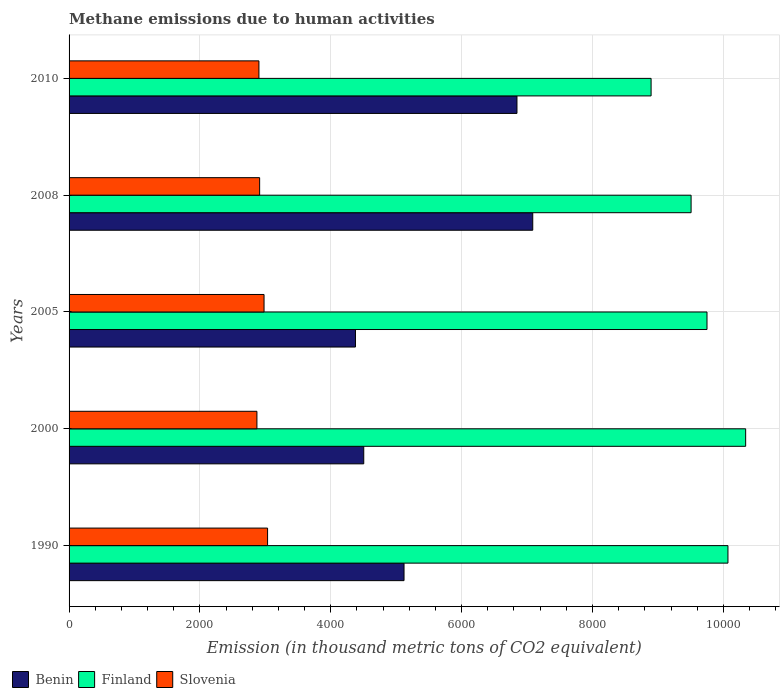How many different coloured bars are there?
Your answer should be compact. 3. How many bars are there on the 3rd tick from the bottom?
Ensure brevity in your answer.  3. What is the label of the 1st group of bars from the top?
Give a very brief answer. 2010. What is the amount of methane emitted in Benin in 2000?
Your answer should be compact. 4503.8. Across all years, what is the maximum amount of methane emitted in Finland?
Ensure brevity in your answer.  1.03e+04. Across all years, what is the minimum amount of methane emitted in Finland?
Provide a succinct answer. 8895.5. In which year was the amount of methane emitted in Finland maximum?
Offer a terse response. 2000. What is the total amount of methane emitted in Slovenia in the graph?
Your response must be concise. 1.47e+04. What is the difference between the amount of methane emitted in Benin in 1990 and that in 2010?
Offer a terse response. -1726.1. What is the difference between the amount of methane emitted in Benin in 2005 and the amount of methane emitted in Slovenia in 2000?
Your response must be concise. 1506.2. What is the average amount of methane emitted in Slovenia per year?
Provide a short and direct response. 2939.82. In the year 2010, what is the difference between the amount of methane emitted in Benin and amount of methane emitted in Finland?
Provide a short and direct response. -2049.9. What is the ratio of the amount of methane emitted in Slovenia in 1990 to that in 2005?
Keep it short and to the point. 1.02. Is the difference between the amount of methane emitted in Benin in 2000 and 2008 greater than the difference between the amount of methane emitted in Finland in 2000 and 2008?
Offer a terse response. No. What is the difference between the highest and the second highest amount of methane emitted in Slovenia?
Your answer should be very brief. 54. What is the difference between the highest and the lowest amount of methane emitted in Benin?
Your answer should be very brief. 2709.3. In how many years, is the amount of methane emitted in Finland greater than the average amount of methane emitted in Finland taken over all years?
Provide a short and direct response. 3. What does the 1st bar from the top in 2005 represents?
Provide a succinct answer. Slovenia. What does the 2nd bar from the bottom in 2010 represents?
Ensure brevity in your answer.  Finland. How many bars are there?
Your response must be concise. 15. Are all the bars in the graph horizontal?
Offer a terse response. Yes. How many years are there in the graph?
Offer a very short reply. 5. Does the graph contain any zero values?
Give a very brief answer. No. Where does the legend appear in the graph?
Give a very brief answer. Bottom left. How are the legend labels stacked?
Offer a terse response. Horizontal. What is the title of the graph?
Give a very brief answer. Methane emissions due to human activities. Does "Jamaica" appear as one of the legend labels in the graph?
Offer a terse response. No. What is the label or title of the X-axis?
Offer a very short reply. Emission (in thousand metric tons of CO2 equivalent). What is the Emission (in thousand metric tons of CO2 equivalent) of Benin in 1990?
Provide a short and direct response. 5119.5. What is the Emission (in thousand metric tons of CO2 equivalent) of Finland in 1990?
Offer a terse response. 1.01e+04. What is the Emission (in thousand metric tons of CO2 equivalent) of Slovenia in 1990?
Your answer should be compact. 3033.9. What is the Emission (in thousand metric tons of CO2 equivalent) in Benin in 2000?
Ensure brevity in your answer.  4503.8. What is the Emission (in thousand metric tons of CO2 equivalent) in Finland in 2000?
Give a very brief answer. 1.03e+04. What is the Emission (in thousand metric tons of CO2 equivalent) of Slovenia in 2000?
Ensure brevity in your answer.  2871.1. What is the Emission (in thousand metric tons of CO2 equivalent) in Benin in 2005?
Ensure brevity in your answer.  4377.3. What is the Emission (in thousand metric tons of CO2 equivalent) in Finland in 2005?
Give a very brief answer. 9750. What is the Emission (in thousand metric tons of CO2 equivalent) of Slovenia in 2005?
Offer a very short reply. 2979.9. What is the Emission (in thousand metric tons of CO2 equivalent) in Benin in 2008?
Your answer should be compact. 7086.6. What is the Emission (in thousand metric tons of CO2 equivalent) of Finland in 2008?
Keep it short and to the point. 9506.7. What is the Emission (in thousand metric tons of CO2 equivalent) of Slovenia in 2008?
Give a very brief answer. 2912.5. What is the Emission (in thousand metric tons of CO2 equivalent) of Benin in 2010?
Your answer should be compact. 6845.6. What is the Emission (in thousand metric tons of CO2 equivalent) in Finland in 2010?
Offer a terse response. 8895.5. What is the Emission (in thousand metric tons of CO2 equivalent) of Slovenia in 2010?
Keep it short and to the point. 2901.7. Across all years, what is the maximum Emission (in thousand metric tons of CO2 equivalent) in Benin?
Ensure brevity in your answer.  7086.6. Across all years, what is the maximum Emission (in thousand metric tons of CO2 equivalent) of Finland?
Provide a succinct answer. 1.03e+04. Across all years, what is the maximum Emission (in thousand metric tons of CO2 equivalent) of Slovenia?
Your answer should be compact. 3033.9. Across all years, what is the minimum Emission (in thousand metric tons of CO2 equivalent) in Benin?
Your answer should be very brief. 4377.3. Across all years, what is the minimum Emission (in thousand metric tons of CO2 equivalent) of Finland?
Make the answer very short. 8895.5. Across all years, what is the minimum Emission (in thousand metric tons of CO2 equivalent) of Slovenia?
Your answer should be compact. 2871.1. What is the total Emission (in thousand metric tons of CO2 equivalent) of Benin in the graph?
Your response must be concise. 2.79e+04. What is the total Emission (in thousand metric tons of CO2 equivalent) in Finland in the graph?
Your answer should be very brief. 4.86e+04. What is the total Emission (in thousand metric tons of CO2 equivalent) of Slovenia in the graph?
Provide a succinct answer. 1.47e+04. What is the difference between the Emission (in thousand metric tons of CO2 equivalent) in Benin in 1990 and that in 2000?
Make the answer very short. 615.7. What is the difference between the Emission (in thousand metric tons of CO2 equivalent) of Finland in 1990 and that in 2000?
Provide a short and direct response. -270.6. What is the difference between the Emission (in thousand metric tons of CO2 equivalent) of Slovenia in 1990 and that in 2000?
Your response must be concise. 162.8. What is the difference between the Emission (in thousand metric tons of CO2 equivalent) in Benin in 1990 and that in 2005?
Offer a terse response. 742.2. What is the difference between the Emission (in thousand metric tons of CO2 equivalent) in Finland in 1990 and that in 2005?
Offer a terse response. 320.2. What is the difference between the Emission (in thousand metric tons of CO2 equivalent) in Benin in 1990 and that in 2008?
Your answer should be very brief. -1967.1. What is the difference between the Emission (in thousand metric tons of CO2 equivalent) of Finland in 1990 and that in 2008?
Ensure brevity in your answer.  563.5. What is the difference between the Emission (in thousand metric tons of CO2 equivalent) of Slovenia in 1990 and that in 2008?
Your answer should be compact. 121.4. What is the difference between the Emission (in thousand metric tons of CO2 equivalent) in Benin in 1990 and that in 2010?
Your response must be concise. -1726.1. What is the difference between the Emission (in thousand metric tons of CO2 equivalent) of Finland in 1990 and that in 2010?
Make the answer very short. 1174.7. What is the difference between the Emission (in thousand metric tons of CO2 equivalent) of Slovenia in 1990 and that in 2010?
Ensure brevity in your answer.  132.2. What is the difference between the Emission (in thousand metric tons of CO2 equivalent) in Benin in 2000 and that in 2005?
Make the answer very short. 126.5. What is the difference between the Emission (in thousand metric tons of CO2 equivalent) in Finland in 2000 and that in 2005?
Offer a terse response. 590.8. What is the difference between the Emission (in thousand metric tons of CO2 equivalent) in Slovenia in 2000 and that in 2005?
Offer a very short reply. -108.8. What is the difference between the Emission (in thousand metric tons of CO2 equivalent) of Benin in 2000 and that in 2008?
Offer a terse response. -2582.8. What is the difference between the Emission (in thousand metric tons of CO2 equivalent) in Finland in 2000 and that in 2008?
Your answer should be compact. 834.1. What is the difference between the Emission (in thousand metric tons of CO2 equivalent) in Slovenia in 2000 and that in 2008?
Your response must be concise. -41.4. What is the difference between the Emission (in thousand metric tons of CO2 equivalent) in Benin in 2000 and that in 2010?
Your answer should be very brief. -2341.8. What is the difference between the Emission (in thousand metric tons of CO2 equivalent) in Finland in 2000 and that in 2010?
Give a very brief answer. 1445.3. What is the difference between the Emission (in thousand metric tons of CO2 equivalent) of Slovenia in 2000 and that in 2010?
Give a very brief answer. -30.6. What is the difference between the Emission (in thousand metric tons of CO2 equivalent) in Benin in 2005 and that in 2008?
Provide a succinct answer. -2709.3. What is the difference between the Emission (in thousand metric tons of CO2 equivalent) of Finland in 2005 and that in 2008?
Your response must be concise. 243.3. What is the difference between the Emission (in thousand metric tons of CO2 equivalent) in Slovenia in 2005 and that in 2008?
Provide a succinct answer. 67.4. What is the difference between the Emission (in thousand metric tons of CO2 equivalent) of Benin in 2005 and that in 2010?
Keep it short and to the point. -2468.3. What is the difference between the Emission (in thousand metric tons of CO2 equivalent) in Finland in 2005 and that in 2010?
Offer a terse response. 854.5. What is the difference between the Emission (in thousand metric tons of CO2 equivalent) in Slovenia in 2005 and that in 2010?
Provide a succinct answer. 78.2. What is the difference between the Emission (in thousand metric tons of CO2 equivalent) of Benin in 2008 and that in 2010?
Your response must be concise. 241. What is the difference between the Emission (in thousand metric tons of CO2 equivalent) of Finland in 2008 and that in 2010?
Your answer should be very brief. 611.2. What is the difference between the Emission (in thousand metric tons of CO2 equivalent) in Slovenia in 2008 and that in 2010?
Provide a succinct answer. 10.8. What is the difference between the Emission (in thousand metric tons of CO2 equivalent) in Benin in 1990 and the Emission (in thousand metric tons of CO2 equivalent) in Finland in 2000?
Your response must be concise. -5221.3. What is the difference between the Emission (in thousand metric tons of CO2 equivalent) of Benin in 1990 and the Emission (in thousand metric tons of CO2 equivalent) of Slovenia in 2000?
Your response must be concise. 2248.4. What is the difference between the Emission (in thousand metric tons of CO2 equivalent) in Finland in 1990 and the Emission (in thousand metric tons of CO2 equivalent) in Slovenia in 2000?
Your response must be concise. 7199.1. What is the difference between the Emission (in thousand metric tons of CO2 equivalent) in Benin in 1990 and the Emission (in thousand metric tons of CO2 equivalent) in Finland in 2005?
Provide a short and direct response. -4630.5. What is the difference between the Emission (in thousand metric tons of CO2 equivalent) in Benin in 1990 and the Emission (in thousand metric tons of CO2 equivalent) in Slovenia in 2005?
Provide a short and direct response. 2139.6. What is the difference between the Emission (in thousand metric tons of CO2 equivalent) in Finland in 1990 and the Emission (in thousand metric tons of CO2 equivalent) in Slovenia in 2005?
Keep it short and to the point. 7090.3. What is the difference between the Emission (in thousand metric tons of CO2 equivalent) in Benin in 1990 and the Emission (in thousand metric tons of CO2 equivalent) in Finland in 2008?
Your answer should be compact. -4387.2. What is the difference between the Emission (in thousand metric tons of CO2 equivalent) in Benin in 1990 and the Emission (in thousand metric tons of CO2 equivalent) in Slovenia in 2008?
Ensure brevity in your answer.  2207. What is the difference between the Emission (in thousand metric tons of CO2 equivalent) in Finland in 1990 and the Emission (in thousand metric tons of CO2 equivalent) in Slovenia in 2008?
Keep it short and to the point. 7157.7. What is the difference between the Emission (in thousand metric tons of CO2 equivalent) of Benin in 1990 and the Emission (in thousand metric tons of CO2 equivalent) of Finland in 2010?
Keep it short and to the point. -3776. What is the difference between the Emission (in thousand metric tons of CO2 equivalent) of Benin in 1990 and the Emission (in thousand metric tons of CO2 equivalent) of Slovenia in 2010?
Provide a short and direct response. 2217.8. What is the difference between the Emission (in thousand metric tons of CO2 equivalent) of Finland in 1990 and the Emission (in thousand metric tons of CO2 equivalent) of Slovenia in 2010?
Provide a short and direct response. 7168.5. What is the difference between the Emission (in thousand metric tons of CO2 equivalent) in Benin in 2000 and the Emission (in thousand metric tons of CO2 equivalent) in Finland in 2005?
Keep it short and to the point. -5246.2. What is the difference between the Emission (in thousand metric tons of CO2 equivalent) in Benin in 2000 and the Emission (in thousand metric tons of CO2 equivalent) in Slovenia in 2005?
Your response must be concise. 1523.9. What is the difference between the Emission (in thousand metric tons of CO2 equivalent) in Finland in 2000 and the Emission (in thousand metric tons of CO2 equivalent) in Slovenia in 2005?
Your answer should be very brief. 7360.9. What is the difference between the Emission (in thousand metric tons of CO2 equivalent) in Benin in 2000 and the Emission (in thousand metric tons of CO2 equivalent) in Finland in 2008?
Your answer should be very brief. -5002.9. What is the difference between the Emission (in thousand metric tons of CO2 equivalent) of Benin in 2000 and the Emission (in thousand metric tons of CO2 equivalent) of Slovenia in 2008?
Your answer should be compact. 1591.3. What is the difference between the Emission (in thousand metric tons of CO2 equivalent) in Finland in 2000 and the Emission (in thousand metric tons of CO2 equivalent) in Slovenia in 2008?
Give a very brief answer. 7428.3. What is the difference between the Emission (in thousand metric tons of CO2 equivalent) of Benin in 2000 and the Emission (in thousand metric tons of CO2 equivalent) of Finland in 2010?
Offer a very short reply. -4391.7. What is the difference between the Emission (in thousand metric tons of CO2 equivalent) in Benin in 2000 and the Emission (in thousand metric tons of CO2 equivalent) in Slovenia in 2010?
Your response must be concise. 1602.1. What is the difference between the Emission (in thousand metric tons of CO2 equivalent) in Finland in 2000 and the Emission (in thousand metric tons of CO2 equivalent) in Slovenia in 2010?
Make the answer very short. 7439.1. What is the difference between the Emission (in thousand metric tons of CO2 equivalent) in Benin in 2005 and the Emission (in thousand metric tons of CO2 equivalent) in Finland in 2008?
Make the answer very short. -5129.4. What is the difference between the Emission (in thousand metric tons of CO2 equivalent) of Benin in 2005 and the Emission (in thousand metric tons of CO2 equivalent) of Slovenia in 2008?
Give a very brief answer. 1464.8. What is the difference between the Emission (in thousand metric tons of CO2 equivalent) in Finland in 2005 and the Emission (in thousand metric tons of CO2 equivalent) in Slovenia in 2008?
Ensure brevity in your answer.  6837.5. What is the difference between the Emission (in thousand metric tons of CO2 equivalent) in Benin in 2005 and the Emission (in thousand metric tons of CO2 equivalent) in Finland in 2010?
Keep it short and to the point. -4518.2. What is the difference between the Emission (in thousand metric tons of CO2 equivalent) in Benin in 2005 and the Emission (in thousand metric tons of CO2 equivalent) in Slovenia in 2010?
Provide a short and direct response. 1475.6. What is the difference between the Emission (in thousand metric tons of CO2 equivalent) of Finland in 2005 and the Emission (in thousand metric tons of CO2 equivalent) of Slovenia in 2010?
Your response must be concise. 6848.3. What is the difference between the Emission (in thousand metric tons of CO2 equivalent) of Benin in 2008 and the Emission (in thousand metric tons of CO2 equivalent) of Finland in 2010?
Provide a short and direct response. -1808.9. What is the difference between the Emission (in thousand metric tons of CO2 equivalent) of Benin in 2008 and the Emission (in thousand metric tons of CO2 equivalent) of Slovenia in 2010?
Provide a short and direct response. 4184.9. What is the difference between the Emission (in thousand metric tons of CO2 equivalent) in Finland in 2008 and the Emission (in thousand metric tons of CO2 equivalent) in Slovenia in 2010?
Make the answer very short. 6605. What is the average Emission (in thousand metric tons of CO2 equivalent) of Benin per year?
Your response must be concise. 5586.56. What is the average Emission (in thousand metric tons of CO2 equivalent) of Finland per year?
Your answer should be compact. 9712.64. What is the average Emission (in thousand metric tons of CO2 equivalent) of Slovenia per year?
Ensure brevity in your answer.  2939.82. In the year 1990, what is the difference between the Emission (in thousand metric tons of CO2 equivalent) of Benin and Emission (in thousand metric tons of CO2 equivalent) of Finland?
Keep it short and to the point. -4950.7. In the year 1990, what is the difference between the Emission (in thousand metric tons of CO2 equivalent) in Benin and Emission (in thousand metric tons of CO2 equivalent) in Slovenia?
Your answer should be compact. 2085.6. In the year 1990, what is the difference between the Emission (in thousand metric tons of CO2 equivalent) of Finland and Emission (in thousand metric tons of CO2 equivalent) of Slovenia?
Ensure brevity in your answer.  7036.3. In the year 2000, what is the difference between the Emission (in thousand metric tons of CO2 equivalent) of Benin and Emission (in thousand metric tons of CO2 equivalent) of Finland?
Your answer should be compact. -5837. In the year 2000, what is the difference between the Emission (in thousand metric tons of CO2 equivalent) of Benin and Emission (in thousand metric tons of CO2 equivalent) of Slovenia?
Your answer should be compact. 1632.7. In the year 2000, what is the difference between the Emission (in thousand metric tons of CO2 equivalent) of Finland and Emission (in thousand metric tons of CO2 equivalent) of Slovenia?
Give a very brief answer. 7469.7. In the year 2005, what is the difference between the Emission (in thousand metric tons of CO2 equivalent) of Benin and Emission (in thousand metric tons of CO2 equivalent) of Finland?
Provide a short and direct response. -5372.7. In the year 2005, what is the difference between the Emission (in thousand metric tons of CO2 equivalent) in Benin and Emission (in thousand metric tons of CO2 equivalent) in Slovenia?
Give a very brief answer. 1397.4. In the year 2005, what is the difference between the Emission (in thousand metric tons of CO2 equivalent) in Finland and Emission (in thousand metric tons of CO2 equivalent) in Slovenia?
Offer a very short reply. 6770.1. In the year 2008, what is the difference between the Emission (in thousand metric tons of CO2 equivalent) of Benin and Emission (in thousand metric tons of CO2 equivalent) of Finland?
Your response must be concise. -2420.1. In the year 2008, what is the difference between the Emission (in thousand metric tons of CO2 equivalent) of Benin and Emission (in thousand metric tons of CO2 equivalent) of Slovenia?
Your response must be concise. 4174.1. In the year 2008, what is the difference between the Emission (in thousand metric tons of CO2 equivalent) of Finland and Emission (in thousand metric tons of CO2 equivalent) of Slovenia?
Provide a succinct answer. 6594.2. In the year 2010, what is the difference between the Emission (in thousand metric tons of CO2 equivalent) of Benin and Emission (in thousand metric tons of CO2 equivalent) of Finland?
Provide a succinct answer. -2049.9. In the year 2010, what is the difference between the Emission (in thousand metric tons of CO2 equivalent) in Benin and Emission (in thousand metric tons of CO2 equivalent) in Slovenia?
Offer a terse response. 3943.9. In the year 2010, what is the difference between the Emission (in thousand metric tons of CO2 equivalent) in Finland and Emission (in thousand metric tons of CO2 equivalent) in Slovenia?
Make the answer very short. 5993.8. What is the ratio of the Emission (in thousand metric tons of CO2 equivalent) in Benin in 1990 to that in 2000?
Your response must be concise. 1.14. What is the ratio of the Emission (in thousand metric tons of CO2 equivalent) in Finland in 1990 to that in 2000?
Provide a short and direct response. 0.97. What is the ratio of the Emission (in thousand metric tons of CO2 equivalent) in Slovenia in 1990 to that in 2000?
Offer a very short reply. 1.06. What is the ratio of the Emission (in thousand metric tons of CO2 equivalent) of Benin in 1990 to that in 2005?
Offer a very short reply. 1.17. What is the ratio of the Emission (in thousand metric tons of CO2 equivalent) in Finland in 1990 to that in 2005?
Keep it short and to the point. 1.03. What is the ratio of the Emission (in thousand metric tons of CO2 equivalent) in Slovenia in 1990 to that in 2005?
Your response must be concise. 1.02. What is the ratio of the Emission (in thousand metric tons of CO2 equivalent) of Benin in 1990 to that in 2008?
Give a very brief answer. 0.72. What is the ratio of the Emission (in thousand metric tons of CO2 equivalent) in Finland in 1990 to that in 2008?
Your response must be concise. 1.06. What is the ratio of the Emission (in thousand metric tons of CO2 equivalent) of Slovenia in 1990 to that in 2008?
Provide a short and direct response. 1.04. What is the ratio of the Emission (in thousand metric tons of CO2 equivalent) in Benin in 1990 to that in 2010?
Provide a succinct answer. 0.75. What is the ratio of the Emission (in thousand metric tons of CO2 equivalent) in Finland in 1990 to that in 2010?
Provide a succinct answer. 1.13. What is the ratio of the Emission (in thousand metric tons of CO2 equivalent) in Slovenia in 1990 to that in 2010?
Give a very brief answer. 1.05. What is the ratio of the Emission (in thousand metric tons of CO2 equivalent) in Benin in 2000 to that in 2005?
Give a very brief answer. 1.03. What is the ratio of the Emission (in thousand metric tons of CO2 equivalent) of Finland in 2000 to that in 2005?
Provide a short and direct response. 1.06. What is the ratio of the Emission (in thousand metric tons of CO2 equivalent) of Slovenia in 2000 to that in 2005?
Offer a very short reply. 0.96. What is the ratio of the Emission (in thousand metric tons of CO2 equivalent) in Benin in 2000 to that in 2008?
Your response must be concise. 0.64. What is the ratio of the Emission (in thousand metric tons of CO2 equivalent) of Finland in 2000 to that in 2008?
Provide a succinct answer. 1.09. What is the ratio of the Emission (in thousand metric tons of CO2 equivalent) in Slovenia in 2000 to that in 2008?
Your response must be concise. 0.99. What is the ratio of the Emission (in thousand metric tons of CO2 equivalent) in Benin in 2000 to that in 2010?
Provide a succinct answer. 0.66. What is the ratio of the Emission (in thousand metric tons of CO2 equivalent) in Finland in 2000 to that in 2010?
Offer a very short reply. 1.16. What is the ratio of the Emission (in thousand metric tons of CO2 equivalent) of Slovenia in 2000 to that in 2010?
Provide a short and direct response. 0.99. What is the ratio of the Emission (in thousand metric tons of CO2 equivalent) in Benin in 2005 to that in 2008?
Provide a short and direct response. 0.62. What is the ratio of the Emission (in thousand metric tons of CO2 equivalent) in Finland in 2005 to that in 2008?
Your response must be concise. 1.03. What is the ratio of the Emission (in thousand metric tons of CO2 equivalent) of Slovenia in 2005 to that in 2008?
Give a very brief answer. 1.02. What is the ratio of the Emission (in thousand metric tons of CO2 equivalent) of Benin in 2005 to that in 2010?
Give a very brief answer. 0.64. What is the ratio of the Emission (in thousand metric tons of CO2 equivalent) in Finland in 2005 to that in 2010?
Your answer should be very brief. 1.1. What is the ratio of the Emission (in thousand metric tons of CO2 equivalent) in Slovenia in 2005 to that in 2010?
Your response must be concise. 1.03. What is the ratio of the Emission (in thousand metric tons of CO2 equivalent) in Benin in 2008 to that in 2010?
Make the answer very short. 1.04. What is the ratio of the Emission (in thousand metric tons of CO2 equivalent) in Finland in 2008 to that in 2010?
Your response must be concise. 1.07. What is the ratio of the Emission (in thousand metric tons of CO2 equivalent) of Slovenia in 2008 to that in 2010?
Keep it short and to the point. 1. What is the difference between the highest and the second highest Emission (in thousand metric tons of CO2 equivalent) of Benin?
Ensure brevity in your answer.  241. What is the difference between the highest and the second highest Emission (in thousand metric tons of CO2 equivalent) of Finland?
Make the answer very short. 270.6. What is the difference between the highest and the lowest Emission (in thousand metric tons of CO2 equivalent) in Benin?
Give a very brief answer. 2709.3. What is the difference between the highest and the lowest Emission (in thousand metric tons of CO2 equivalent) in Finland?
Offer a very short reply. 1445.3. What is the difference between the highest and the lowest Emission (in thousand metric tons of CO2 equivalent) of Slovenia?
Offer a terse response. 162.8. 